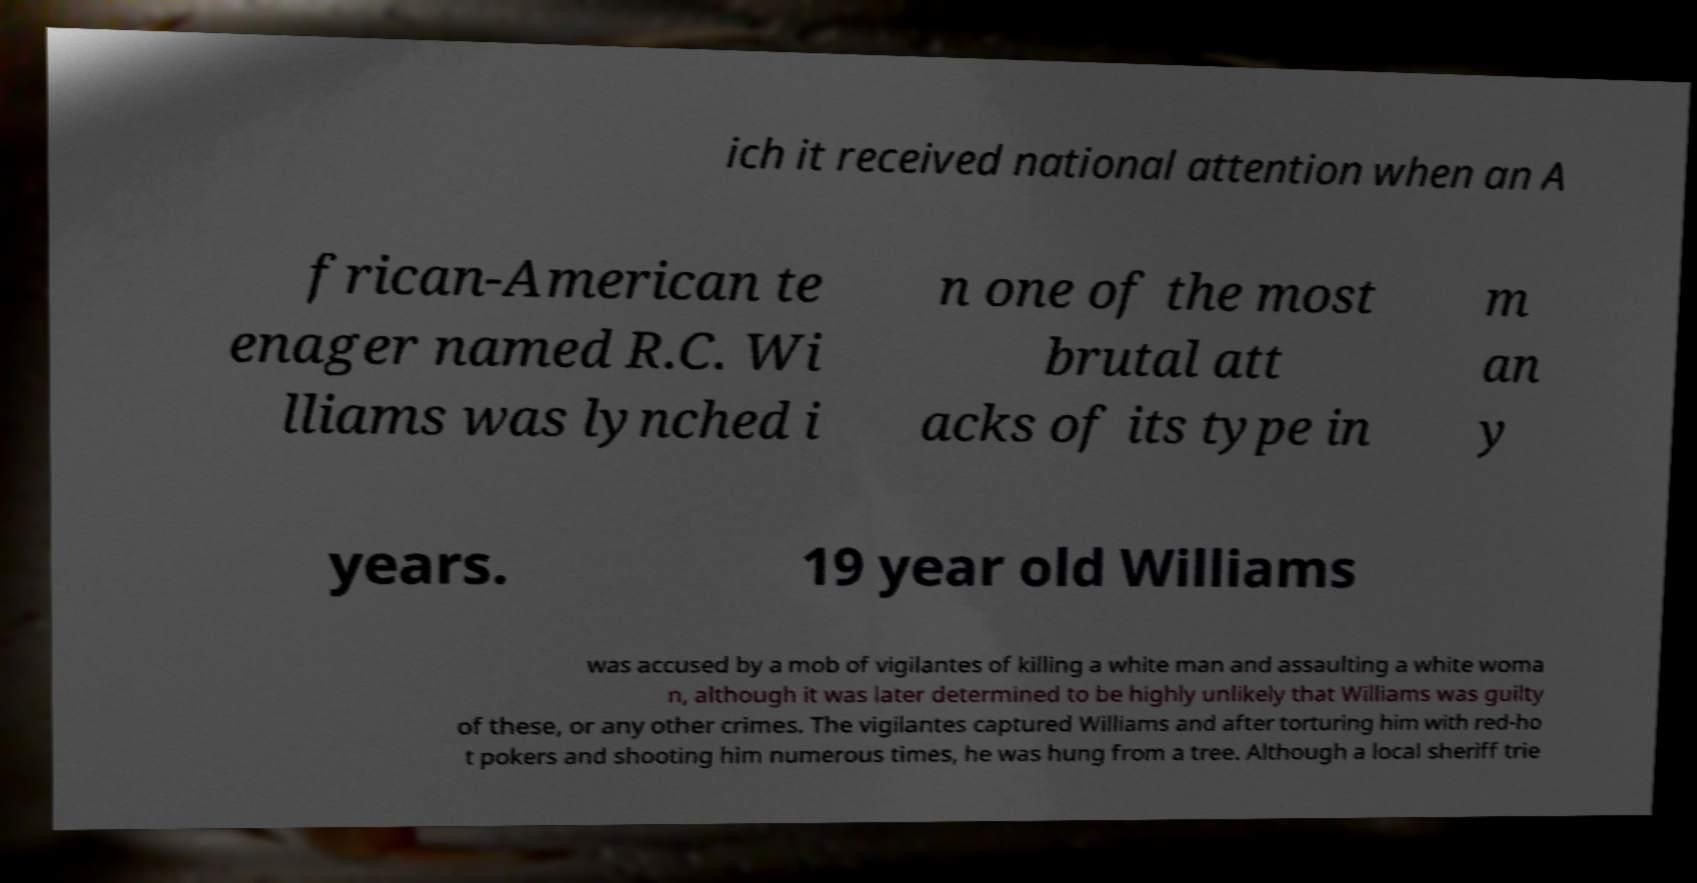Could you extract and type out the text from this image? ich it received national attention when an A frican-American te enager named R.C. Wi lliams was lynched i n one of the most brutal att acks of its type in m an y years. 19 year old Williams was accused by a mob of vigilantes of killing a white man and assaulting a white woma n, although it was later determined to be highly unlikely that Williams was guilty of these, or any other crimes. The vigilantes captured Williams and after torturing him with red-ho t pokers and shooting him numerous times, he was hung from a tree. Although a local sheriff trie 